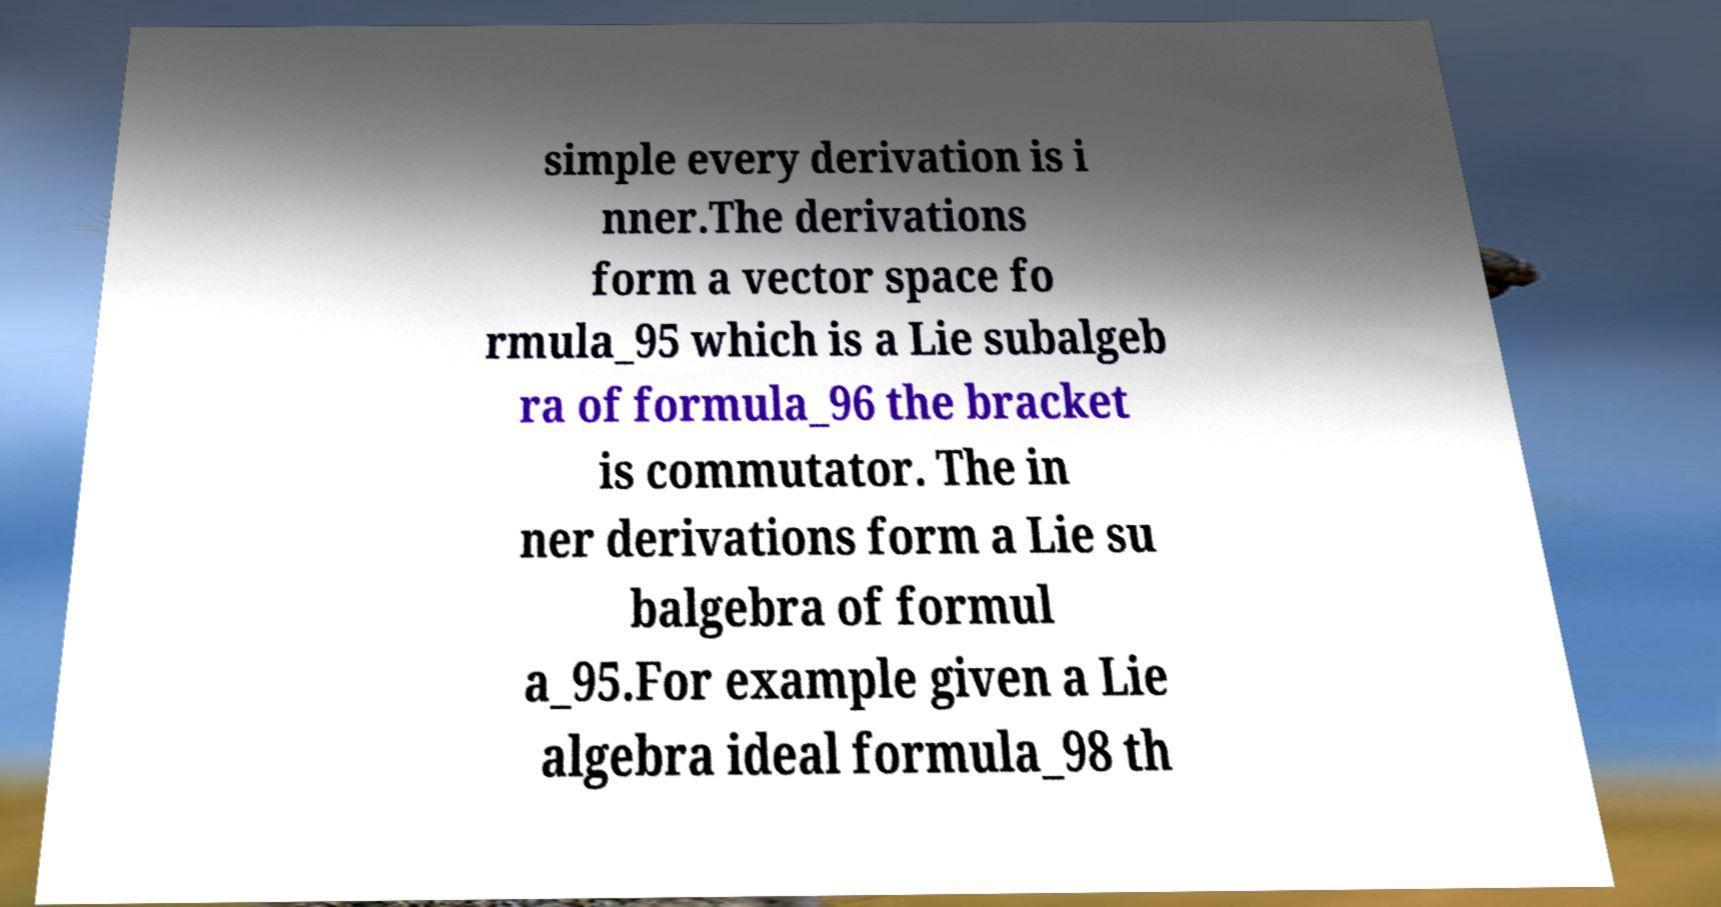I need the written content from this picture converted into text. Can you do that? simple every derivation is i nner.The derivations form a vector space fo rmula_95 which is a Lie subalgeb ra of formula_96 the bracket is commutator. The in ner derivations form a Lie su balgebra of formul a_95.For example given a Lie algebra ideal formula_98 th 